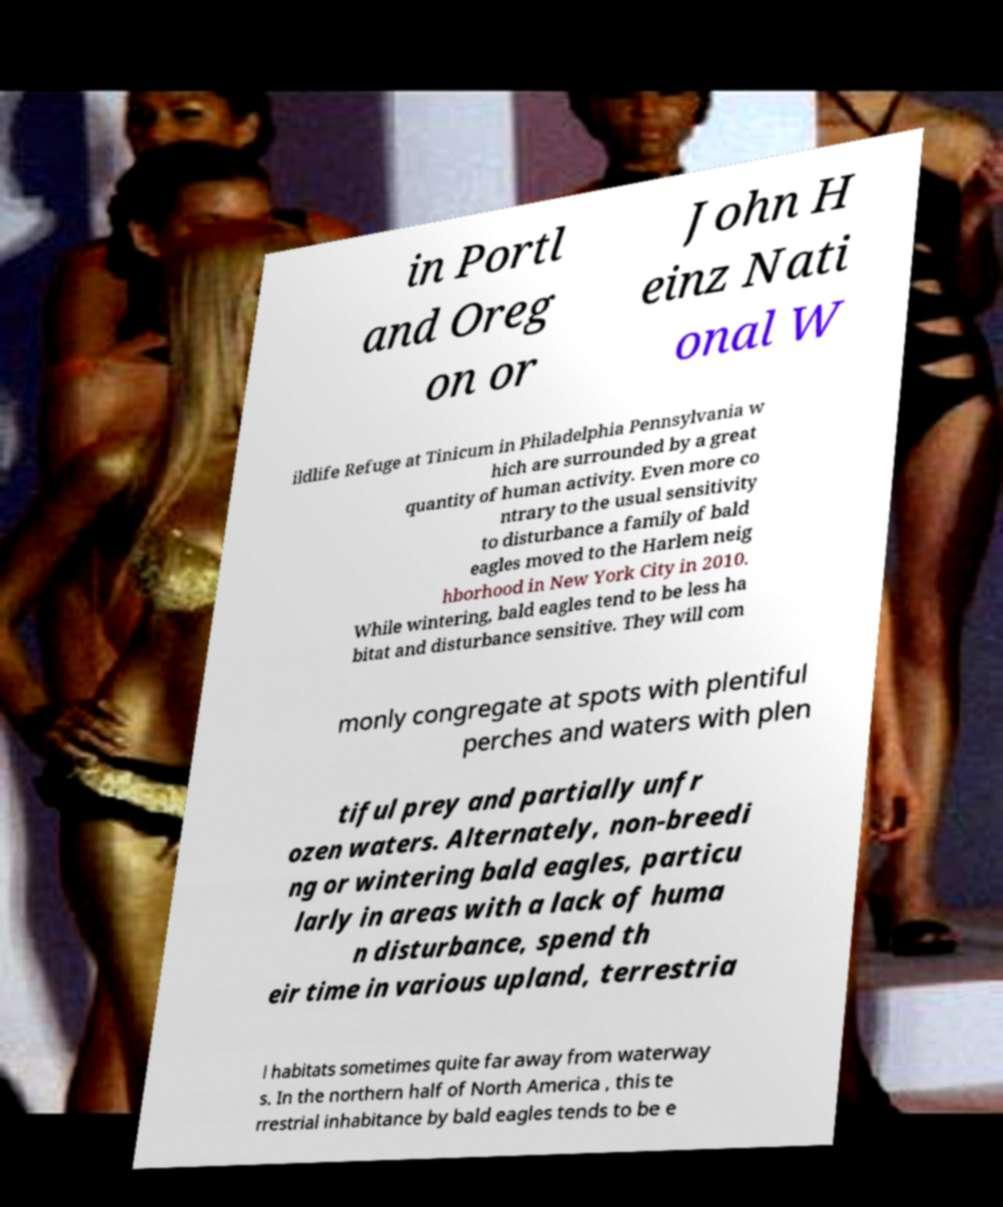Could you assist in decoding the text presented in this image and type it out clearly? in Portl and Oreg on or John H einz Nati onal W ildlife Refuge at Tinicum in Philadelphia Pennsylvania w hich are surrounded by a great quantity of human activity. Even more co ntrary to the usual sensitivity to disturbance a family of bald eagles moved to the Harlem neig hborhood in New York City in 2010. While wintering, bald eagles tend to be less ha bitat and disturbance sensitive. They will com monly congregate at spots with plentiful perches and waters with plen tiful prey and partially unfr ozen waters. Alternately, non-breedi ng or wintering bald eagles, particu larly in areas with a lack of huma n disturbance, spend th eir time in various upland, terrestria l habitats sometimes quite far away from waterway s. In the northern half of North America , this te rrestrial inhabitance by bald eagles tends to be e 